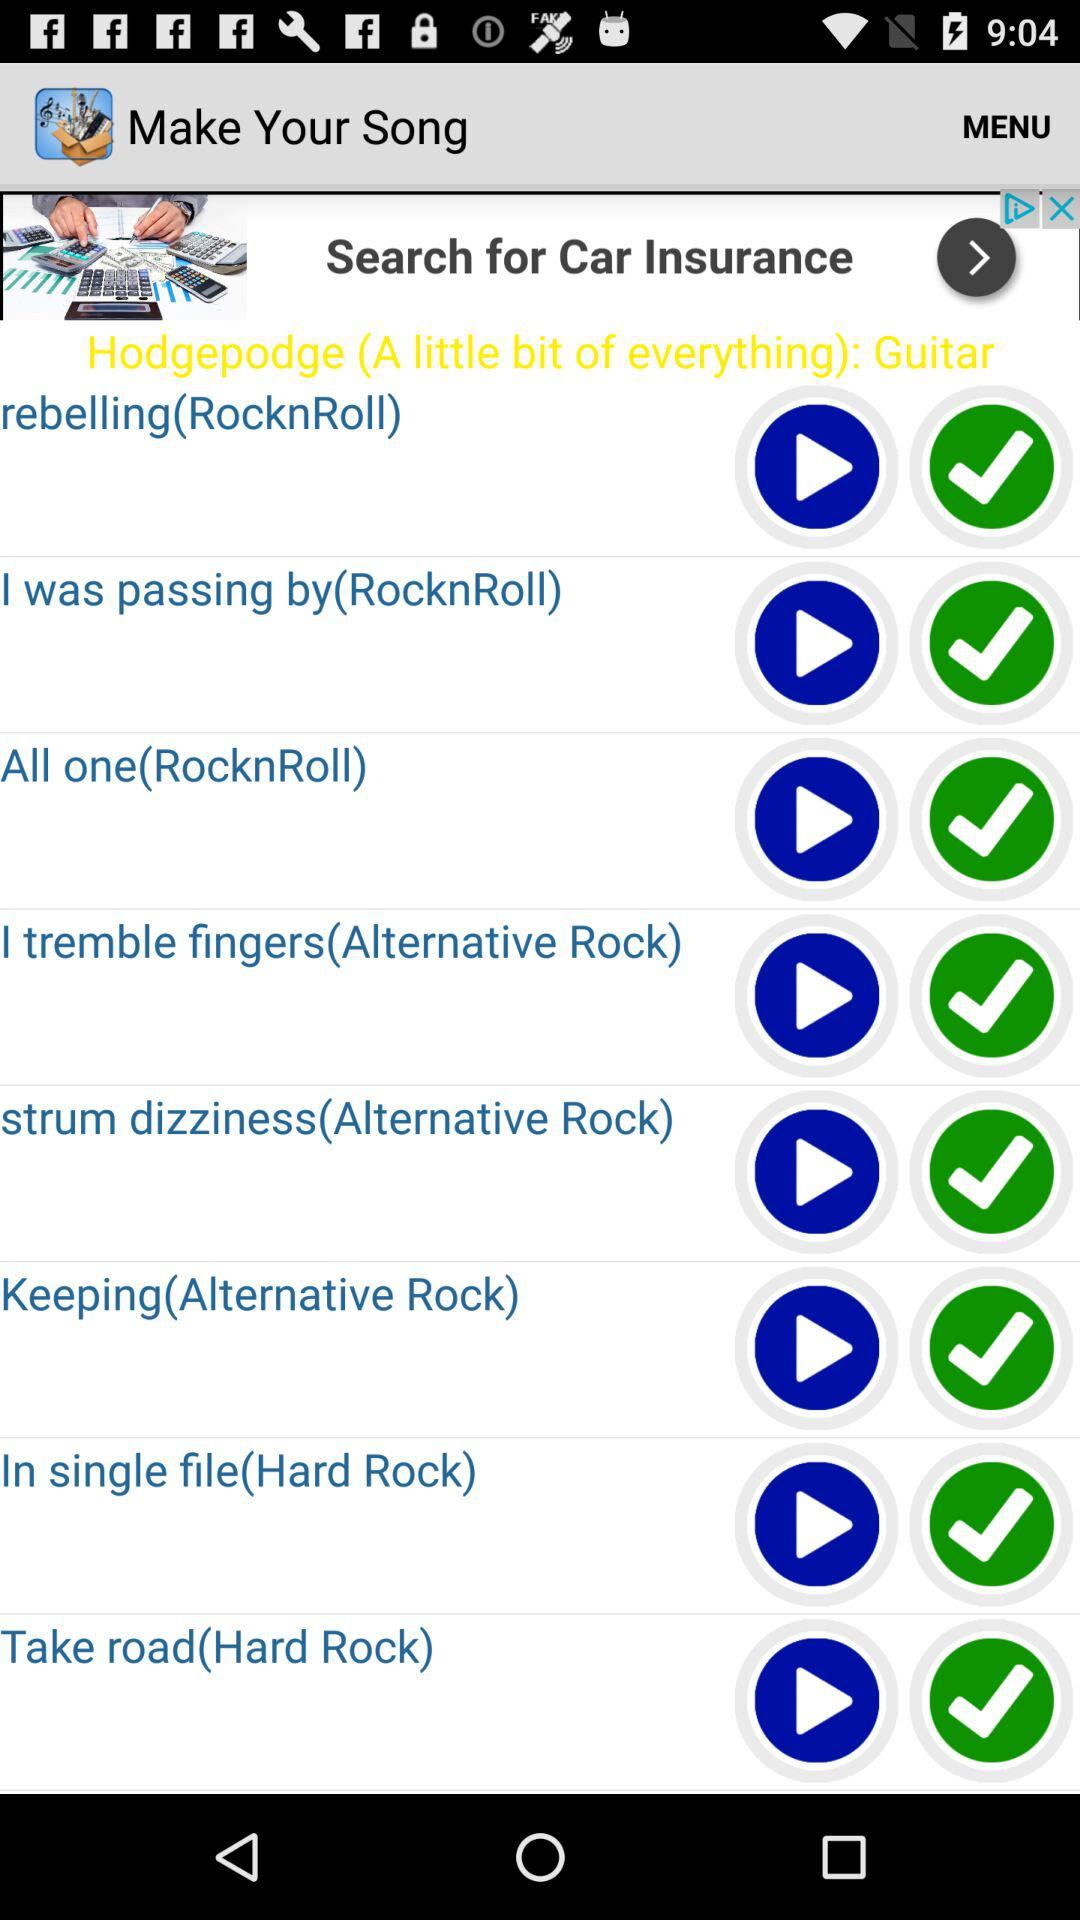How many songs are in the Hard Rock genre?
Answer the question using a single word or phrase. 2 